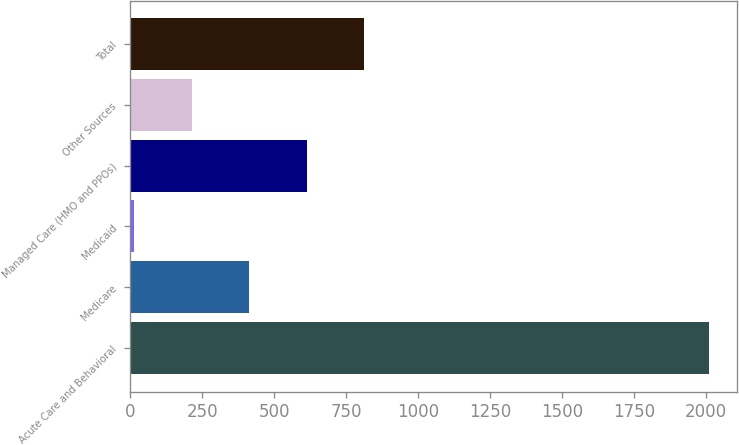<chart> <loc_0><loc_0><loc_500><loc_500><bar_chart><fcel>Acute Care and Behavioral<fcel>Medicare<fcel>Medicaid<fcel>Managed Care (HMO and PPOs)<fcel>Other Sources<fcel>Total<nl><fcel>2008<fcel>412.8<fcel>14<fcel>612.2<fcel>213.4<fcel>811.6<nl></chart> 